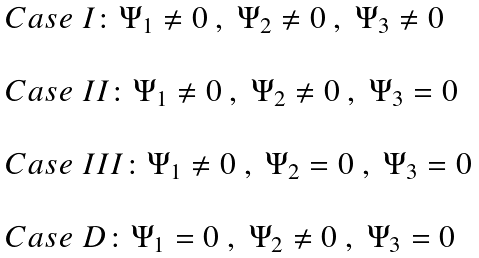Convert formula to latex. <formula><loc_0><loc_0><loc_500><loc_500>\begin{array} { l } C a s e \ I \colon \Psi _ { 1 } \neq 0 \ , \ \Psi _ { 2 } \neq 0 \ , \ \Psi _ { 3 } \neq 0 \\ \\ C a s e \ I I \colon \Psi _ { 1 } \neq 0 \ , \ \Psi _ { 2 } \neq 0 \ , \ \Psi _ { 3 } = 0 \\ \\ C a s e \ I I I \colon \Psi _ { 1 } \neq 0 \ , \ \Psi _ { 2 } = 0 \ , \ \Psi _ { 3 } = 0 \\ \\ C a s e \ D \colon \Psi _ { 1 } = 0 \ , \ \Psi _ { 2 } \neq 0 \ , \ \Psi _ { 3 } = 0 \\ \end{array}</formula> 